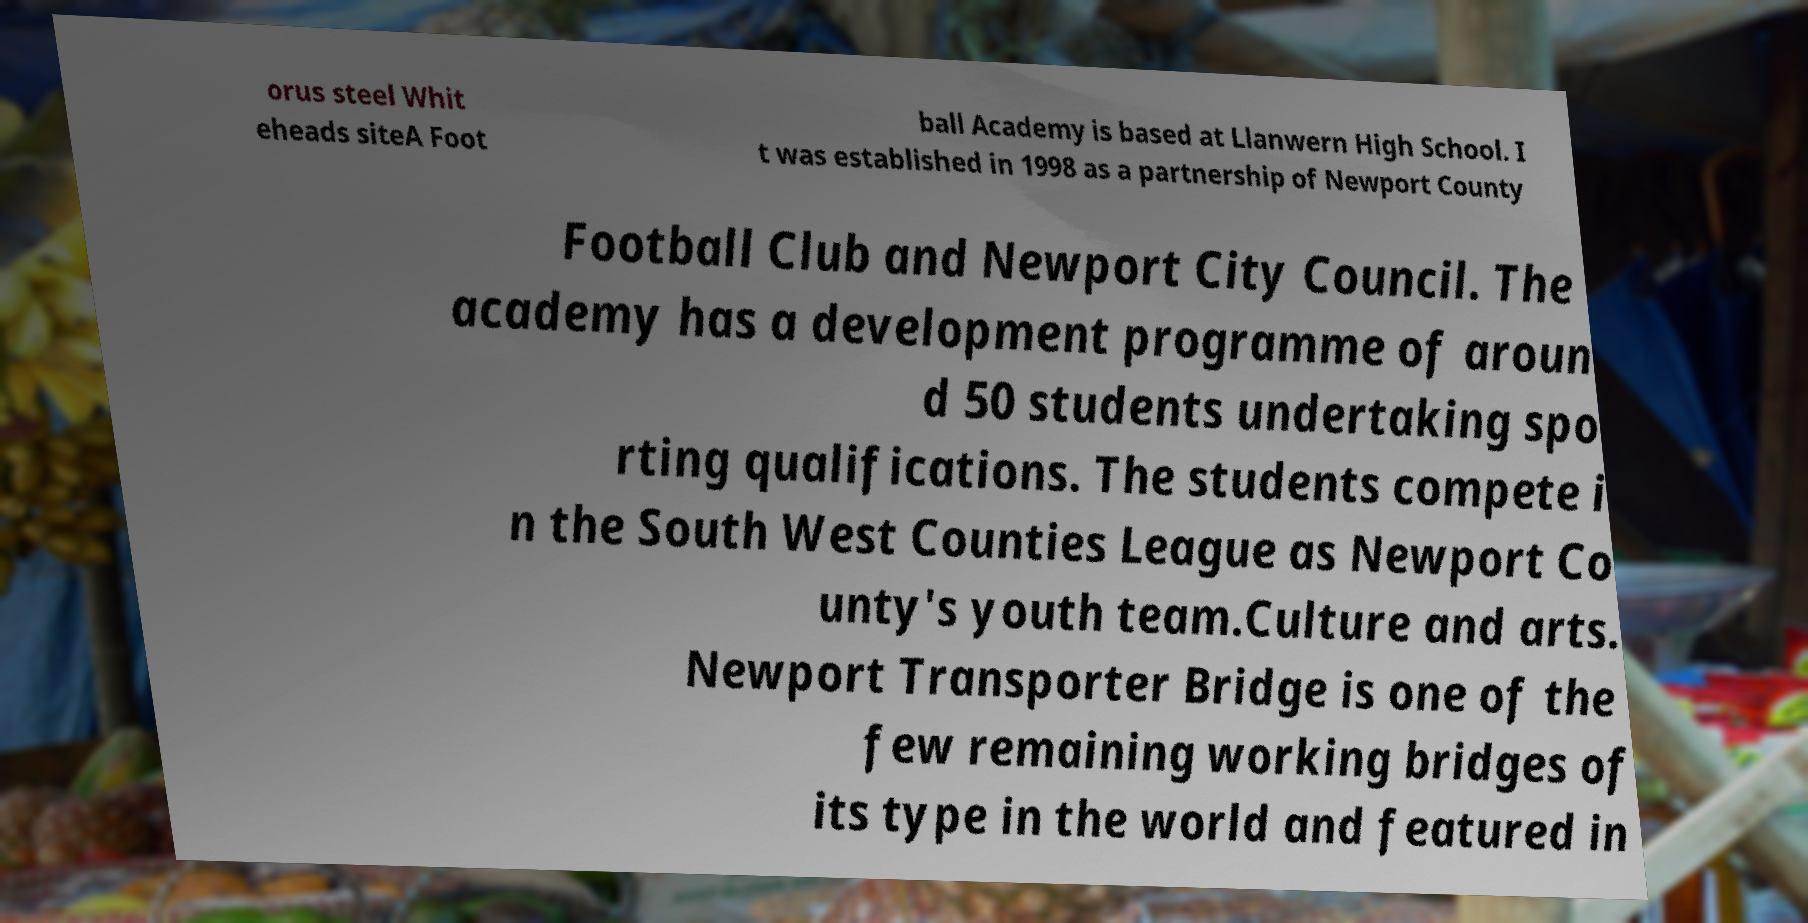There's text embedded in this image that I need extracted. Can you transcribe it verbatim? orus steel Whit eheads siteA Foot ball Academy is based at Llanwern High School. I t was established in 1998 as a partnership of Newport County Football Club and Newport City Council. The academy has a development programme of aroun d 50 students undertaking spo rting qualifications. The students compete i n the South West Counties League as Newport Co unty's youth team.Culture and arts. Newport Transporter Bridge is one of the few remaining working bridges of its type in the world and featured in 